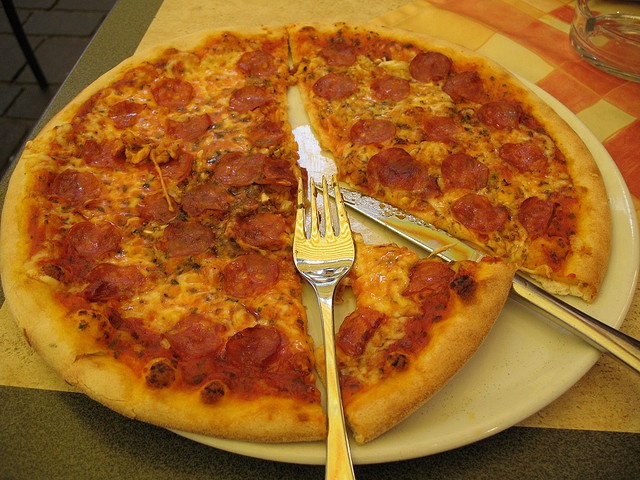Describe the objects in this image and their specific colors. I can see dining table in red, maroon, orange, and tan tones, pizza in black, brown, maroon, and orange tones, pizza in black, red, maroon, and orange tones, fork in black, gold, olive, tan, and khaki tones, and knife in black, olive, and tan tones in this image. 